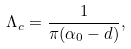Convert formula to latex. <formula><loc_0><loc_0><loc_500><loc_500>\Lambda _ { c } = \frac { 1 } { \pi ( \alpha _ { 0 } - d ) } ,</formula> 